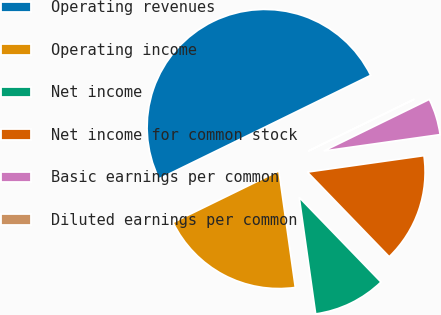Convert chart to OTSL. <chart><loc_0><loc_0><loc_500><loc_500><pie_chart><fcel>Operating revenues<fcel>Operating income<fcel>Net income<fcel>Net income for common stock<fcel>Basic earnings per common<fcel>Diluted earnings per common<nl><fcel>49.98%<fcel>20.0%<fcel>10.0%<fcel>15.0%<fcel>5.01%<fcel>0.01%<nl></chart> 